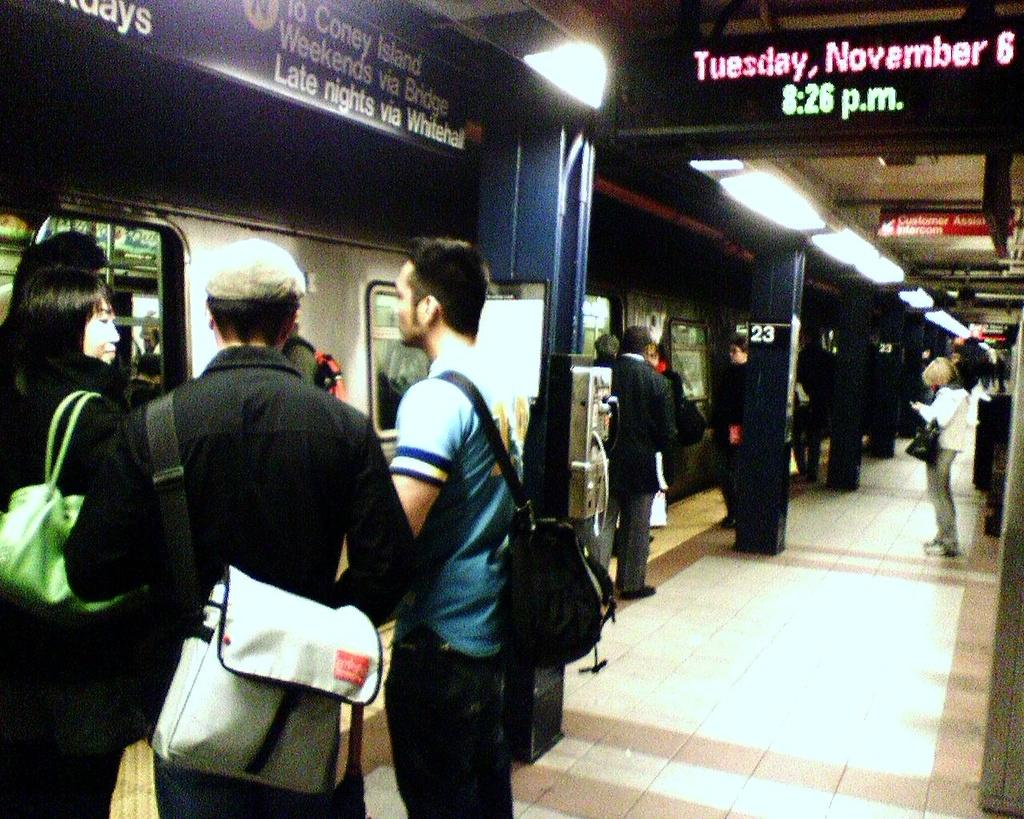How many people are in the image? There are many people in the image. What are the people wearing? The people are wearing bags. Where are the people standing? The people are standing on a platform. What can be seen on the left side of the image? There is a train on the left side of the image. What is located at the top of the image? There is a board at the top of the image. What is written on the board? There is text visible on the board. What type of cherries are being picked by the grandmother in the image? There is no grandmother or cherries present in the image. 